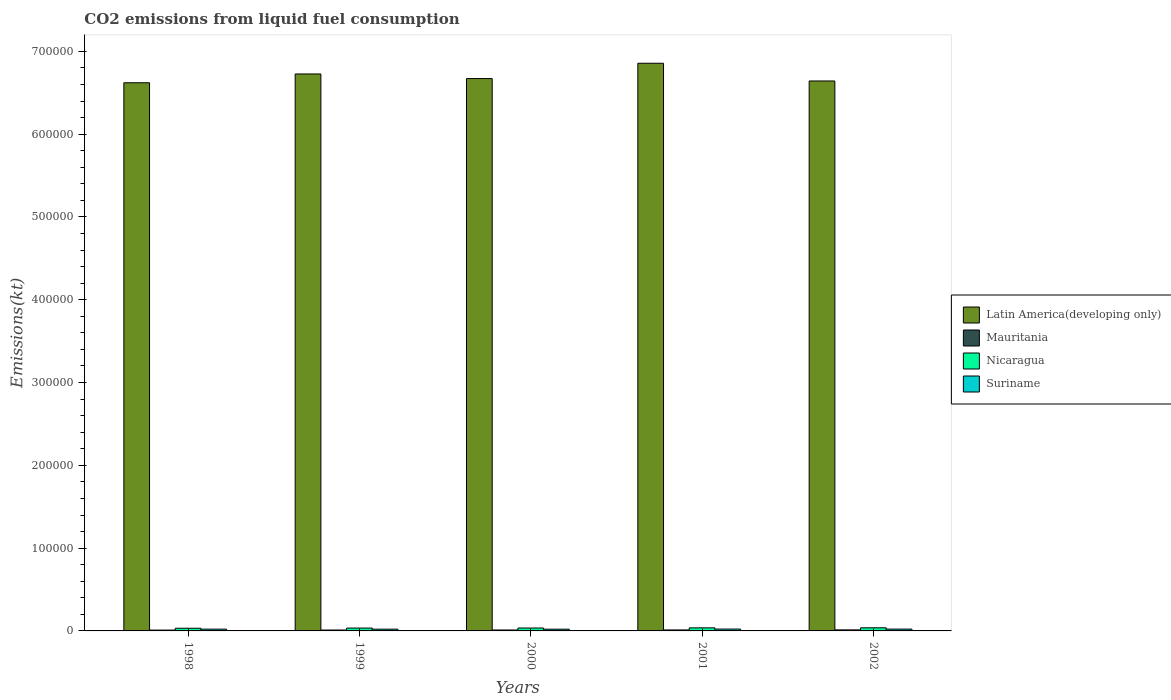How many different coloured bars are there?
Offer a very short reply. 4. How many groups of bars are there?
Provide a succinct answer. 5. Are the number of bars on each tick of the X-axis equal?
Your response must be concise. Yes. What is the label of the 1st group of bars from the left?
Give a very brief answer. 1998. In how many cases, is the number of bars for a given year not equal to the number of legend labels?
Make the answer very short. 0. What is the amount of CO2 emitted in Nicaragua in 2001?
Your answer should be very brief. 3707.34. Across all years, what is the maximum amount of CO2 emitted in Nicaragua?
Provide a succinct answer. 3762.34. Across all years, what is the minimum amount of CO2 emitted in Latin America(developing only)?
Make the answer very short. 6.62e+05. In which year was the amount of CO2 emitted in Suriname minimum?
Your answer should be compact. 2000. What is the total amount of CO2 emitted in Mauritania in the graph?
Your response must be concise. 5643.51. What is the difference between the amount of CO2 emitted in Mauritania in 1999 and that in 2002?
Ensure brevity in your answer.  -172.35. What is the difference between the amount of CO2 emitted in Suriname in 2000 and the amount of CO2 emitted in Nicaragua in 2001?
Offer a very short reply. -1609.81. What is the average amount of CO2 emitted in Nicaragua per year?
Your answer should be compact. 3530.59. In the year 2002, what is the difference between the amount of CO2 emitted in Latin America(developing only) and amount of CO2 emitted in Suriname?
Your response must be concise. 6.62e+05. What is the ratio of the amount of CO2 emitted in Mauritania in 1999 to that in 2001?
Provide a short and direct response. 0.91. Is the amount of CO2 emitted in Mauritania in 1998 less than that in 2000?
Your answer should be very brief. Yes. Is the difference between the amount of CO2 emitted in Latin America(developing only) in 2000 and 2002 greater than the difference between the amount of CO2 emitted in Suriname in 2000 and 2002?
Offer a terse response. Yes. What is the difference between the highest and the second highest amount of CO2 emitted in Mauritania?
Offer a terse response. 69.67. What is the difference between the highest and the lowest amount of CO2 emitted in Mauritania?
Your answer should be compact. 245.69. In how many years, is the amount of CO2 emitted in Mauritania greater than the average amount of CO2 emitted in Mauritania taken over all years?
Ensure brevity in your answer.  2. What does the 4th bar from the left in 2001 represents?
Provide a short and direct response. Suriname. What does the 3rd bar from the right in 1998 represents?
Give a very brief answer. Mauritania. Is it the case that in every year, the sum of the amount of CO2 emitted in Nicaragua and amount of CO2 emitted in Latin America(developing only) is greater than the amount of CO2 emitted in Suriname?
Your response must be concise. Yes. Are all the bars in the graph horizontal?
Offer a very short reply. No. What is the difference between two consecutive major ticks on the Y-axis?
Provide a succinct answer. 1.00e+05. Are the values on the major ticks of Y-axis written in scientific E-notation?
Offer a terse response. No. Does the graph contain any zero values?
Provide a succinct answer. No. Where does the legend appear in the graph?
Your response must be concise. Center right. What is the title of the graph?
Your response must be concise. CO2 emissions from liquid fuel consumption. Does "Burundi" appear as one of the legend labels in the graph?
Provide a succinct answer. No. What is the label or title of the X-axis?
Your response must be concise. Years. What is the label or title of the Y-axis?
Offer a very short reply. Emissions(kt). What is the Emissions(kt) in Latin America(developing only) in 1998?
Make the answer very short. 6.62e+05. What is the Emissions(kt) in Mauritania in 1998?
Make the answer very short. 1008.42. What is the Emissions(kt) of Nicaragua in 1998?
Offer a terse response. 3234.29. What is the Emissions(kt) of Suriname in 1998?
Your response must be concise. 2134.19. What is the Emissions(kt) of Latin America(developing only) in 1999?
Your answer should be compact. 6.73e+05. What is the Emissions(kt) in Mauritania in 1999?
Your answer should be compact. 1081.77. What is the Emissions(kt) of Nicaragua in 1999?
Make the answer very short. 3450.65. What is the Emissions(kt) of Suriname in 1999?
Make the answer very short. 2123.19. What is the Emissions(kt) in Latin America(developing only) in 2000?
Provide a short and direct response. 6.67e+05. What is the Emissions(kt) of Mauritania in 2000?
Offer a very short reply. 1114.77. What is the Emissions(kt) in Nicaragua in 2000?
Your answer should be very brief. 3498.32. What is the Emissions(kt) in Suriname in 2000?
Give a very brief answer. 2097.52. What is the Emissions(kt) in Latin America(developing only) in 2001?
Offer a terse response. 6.86e+05. What is the Emissions(kt) of Mauritania in 2001?
Keep it short and to the point. 1184.44. What is the Emissions(kt) in Nicaragua in 2001?
Your answer should be very brief. 3707.34. What is the Emissions(kt) in Suriname in 2001?
Provide a short and direct response. 2233.2. What is the Emissions(kt) in Latin America(developing only) in 2002?
Your response must be concise. 6.64e+05. What is the Emissions(kt) in Mauritania in 2002?
Provide a short and direct response. 1254.11. What is the Emissions(kt) in Nicaragua in 2002?
Provide a succinct answer. 3762.34. What is the Emissions(kt) of Suriname in 2002?
Provide a short and direct response. 2218.53. Across all years, what is the maximum Emissions(kt) of Latin America(developing only)?
Give a very brief answer. 6.86e+05. Across all years, what is the maximum Emissions(kt) of Mauritania?
Keep it short and to the point. 1254.11. Across all years, what is the maximum Emissions(kt) of Nicaragua?
Ensure brevity in your answer.  3762.34. Across all years, what is the maximum Emissions(kt) in Suriname?
Keep it short and to the point. 2233.2. Across all years, what is the minimum Emissions(kt) in Latin America(developing only)?
Offer a terse response. 6.62e+05. Across all years, what is the minimum Emissions(kt) of Mauritania?
Offer a very short reply. 1008.42. Across all years, what is the minimum Emissions(kt) of Nicaragua?
Your answer should be very brief. 3234.29. Across all years, what is the minimum Emissions(kt) of Suriname?
Your response must be concise. 2097.52. What is the total Emissions(kt) in Latin America(developing only) in the graph?
Your answer should be compact. 3.35e+06. What is the total Emissions(kt) in Mauritania in the graph?
Your answer should be very brief. 5643.51. What is the total Emissions(kt) of Nicaragua in the graph?
Your response must be concise. 1.77e+04. What is the total Emissions(kt) in Suriname in the graph?
Ensure brevity in your answer.  1.08e+04. What is the difference between the Emissions(kt) of Latin America(developing only) in 1998 and that in 1999?
Offer a terse response. -1.06e+04. What is the difference between the Emissions(kt) in Mauritania in 1998 and that in 1999?
Provide a succinct answer. -73.34. What is the difference between the Emissions(kt) in Nicaragua in 1998 and that in 1999?
Offer a terse response. -216.35. What is the difference between the Emissions(kt) of Suriname in 1998 and that in 1999?
Keep it short and to the point. 11. What is the difference between the Emissions(kt) of Latin America(developing only) in 1998 and that in 2000?
Your response must be concise. -5056.79. What is the difference between the Emissions(kt) of Mauritania in 1998 and that in 2000?
Your response must be concise. -106.34. What is the difference between the Emissions(kt) in Nicaragua in 1998 and that in 2000?
Provide a succinct answer. -264.02. What is the difference between the Emissions(kt) in Suriname in 1998 and that in 2000?
Make the answer very short. 36.67. What is the difference between the Emissions(kt) in Latin America(developing only) in 1998 and that in 2001?
Your answer should be very brief. -2.36e+04. What is the difference between the Emissions(kt) in Mauritania in 1998 and that in 2001?
Provide a succinct answer. -176.02. What is the difference between the Emissions(kt) of Nicaragua in 1998 and that in 2001?
Make the answer very short. -473.04. What is the difference between the Emissions(kt) of Suriname in 1998 and that in 2001?
Ensure brevity in your answer.  -99.01. What is the difference between the Emissions(kt) of Latin America(developing only) in 1998 and that in 2002?
Your response must be concise. -2156.2. What is the difference between the Emissions(kt) in Mauritania in 1998 and that in 2002?
Offer a very short reply. -245.69. What is the difference between the Emissions(kt) of Nicaragua in 1998 and that in 2002?
Provide a short and direct response. -528.05. What is the difference between the Emissions(kt) in Suriname in 1998 and that in 2002?
Your response must be concise. -84.34. What is the difference between the Emissions(kt) in Latin America(developing only) in 1999 and that in 2000?
Your response must be concise. 5577.51. What is the difference between the Emissions(kt) in Mauritania in 1999 and that in 2000?
Keep it short and to the point. -33. What is the difference between the Emissions(kt) in Nicaragua in 1999 and that in 2000?
Offer a terse response. -47.67. What is the difference between the Emissions(kt) of Suriname in 1999 and that in 2000?
Offer a terse response. 25.67. What is the difference between the Emissions(kt) in Latin America(developing only) in 1999 and that in 2001?
Your answer should be compact. -1.29e+04. What is the difference between the Emissions(kt) in Mauritania in 1999 and that in 2001?
Your answer should be very brief. -102.68. What is the difference between the Emissions(kt) of Nicaragua in 1999 and that in 2001?
Your answer should be very brief. -256.69. What is the difference between the Emissions(kt) of Suriname in 1999 and that in 2001?
Provide a succinct answer. -110.01. What is the difference between the Emissions(kt) of Latin America(developing only) in 1999 and that in 2002?
Give a very brief answer. 8478.1. What is the difference between the Emissions(kt) of Mauritania in 1999 and that in 2002?
Your answer should be compact. -172.35. What is the difference between the Emissions(kt) in Nicaragua in 1999 and that in 2002?
Your answer should be compact. -311.69. What is the difference between the Emissions(kt) of Suriname in 1999 and that in 2002?
Your answer should be compact. -95.34. What is the difference between the Emissions(kt) of Latin America(developing only) in 2000 and that in 2001?
Provide a short and direct response. -1.85e+04. What is the difference between the Emissions(kt) in Mauritania in 2000 and that in 2001?
Make the answer very short. -69.67. What is the difference between the Emissions(kt) in Nicaragua in 2000 and that in 2001?
Provide a succinct answer. -209.02. What is the difference between the Emissions(kt) in Suriname in 2000 and that in 2001?
Give a very brief answer. -135.68. What is the difference between the Emissions(kt) in Latin America(developing only) in 2000 and that in 2002?
Your answer should be very brief. 2900.6. What is the difference between the Emissions(kt) of Mauritania in 2000 and that in 2002?
Ensure brevity in your answer.  -139.35. What is the difference between the Emissions(kt) of Nicaragua in 2000 and that in 2002?
Your answer should be compact. -264.02. What is the difference between the Emissions(kt) in Suriname in 2000 and that in 2002?
Make the answer very short. -121.01. What is the difference between the Emissions(kt) of Latin America(developing only) in 2001 and that in 2002?
Offer a very short reply. 2.14e+04. What is the difference between the Emissions(kt) of Mauritania in 2001 and that in 2002?
Give a very brief answer. -69.67. What is the difference between the Emissions(kt) of Nicaragua in 2001 and that in 2002?
Make the answer very short. -55.01. What is the difference between the Emissions(kt) of Suriname in 2001 and that in 2002?
Your answer should be compact. 14.67. What is the difference between the Emissions(kt) of Latin America(developing only) in 1998 and the Emissions(kt) of Mauritania in 1999?
Provide a short and direct response. 6.61e+05. What is the difference between the Emissions(kt) in Latin America(developing only) in 1998 and the Emissions(kt) in Nicaragua in 1999?
Keep it short and to the point. 6.59e+05. What is the difference between the Emissions(kt) in Latin America(developing only) in 1998 and the Emissions(kt) in Suriname in 1999?
Keep it short and to the point. 6.60e+05. What is the difference between the Emissions(kt) in Mauritania in 1998 and the Emissions(kt) in Nicaragua in 1999?
Provide a succinct answer. -2442.22. What is the difference between the Emissions(kt) in Mauritania in 1998 and the Emissions(kt) in Suriname in 1999?
Keep it short and to the point. -1114.77. What is the difference between the Emissions(kt) of Nicaragua in 1998 and the Emissions(kt) of Suriname in 1999?
Your response must be concise. 1111.1. What is the difference between the Emissions(kt) of Latin America(developing only) in 1998 and the Emissions(kt) of Mauritania in 2000?
Your answer should be very brief. 6.61e+05. What is the difference between the Emissions(kt) in Latin America(developing only) in 1998 and the Emissions(kt) in Nicaragua in 2000?
Your answer should be very brief. 6.59e+05. What is the difference between the Emissions(kt) of Latin America(developing only) in 1998 and the Emissions(kt) of Suriname in 2000?
Offer a very short reply. 6.60e+05. What is the difference between the Emissions(kt) of Mauritania in 1998 and the Emissions(kt) of Nicaragua in 2000?
Give a very brief answer. -2489.89. What is the difference between the Emissions(kt) of Mauritania in 1998 and the Emissions(kt) of Suriname in 2000?
Provide a succinct answer. -1089.1. What is the difference between the Emissions(kt) in Nicaragua in 1998 and the Emissions(kt) in Suriname in 2000?
Ensure brevity in your answer.  1136.77. What is the difference between the Emissions(kt) in Latin America(developing only) in 1998 and the Emissions(kt) in Mauritania in 2001?
Keep it short and to the point. 6.61e+05. What is the difference between the Emissions(kt) of Latin America(developing only) in 1998 and the Emissions(kt) of Nicaragua in 2001?
Your answer should be compact. 6.58e+05. What is the difference between the Emissions(kt) in Latin America(developing only) in 1998 and the Emissions(kt) in Suriname in 2001?
Ensure brevity in your answer.  6.60e+05. What is the difference between the Emissions(kt) of Mauritania in 1998 and the Emissions(kt) of Nicaragua in 2001?
Your response must be concise. -2698.91. What is the difference between the Emissions(kt) of Mauritania in 1998 and the Emissions(kt) of Suriname in 2001?
Provide a succinct answer. -1224.78. What is the difference between the Emissions(kt) of Nicaragua in 1998 and the Emissions(kt) of Suriname in 2001?
Offer a terse response. 1001.09. What is the difference between the Emissions(kt) in Latin America(developing only) in 1998 and the Emissions(kt) in Mauritania in 2002?
Offer a very short reply. 6.61e+05. What is the difference between the Emissions(kt) of Latin America(developing only) in 1998 and the Emissions(kt) of Nicaragua in 2002?
Ensure brevity in your answer.  6.58e+05. What is the difference between the Emissions(kt) of Latin America(developing only) in 1998 and the Emissions(kt) of Suriname in 2002?
Ensure brevity in your answer.  6.60e+05. What is the difference between the Emissions(kt) in Mauritania in 1998 and the Emissions(kt) in Nicaragua in 2002?
Give a very brief answer. -2753.92. What is the difference between the Emissions(kt) of Mauritania in 1998 and the Emissions(kt) of Suriname in 2002?
Keep it short and to the point. -1210.11. What is the difference between the Emissions(kt) of Nicaragua in 1998 and the Emissions(kt) of Suriname in 2002?
Give a very brief answer. 1015.76. What is the difference between the Emissions(kt) of Latin America(developing only) in 1999 and the Emissions(kt) of Mauritania in 2000?
Give a very brief answer. 6.72e+05. What is the difference between the Emissions(kt) in Latin America(developing only) in 1999 and the Emissions(kt) in Nicaragua in 2000?
Ensure brevity in your answer.  6.69e+05. What is the difference between the Emissions(kt) in Latin America(developing only) in 1999 and the Emissions(kt) in Suriname in 2000?
Provide a succinct answer. 6.71e+05. What is the difference between the Emissions(kt) in Mauritania in 1999 and the Emissions(kt) in Nicaragua in 2000?
Ensure brevity in your answer.  -2416.55. What is the difference between the Emissions(kt) of Mauritania in 1999 and the Emissions(kt) of Suriname in 2000?
Ensure brevity in your answer.  -1015.76. What is the difference between the Emissions(kt) in Nicaragua in 1999 and the Emissions(kt) in Suriname in 2000?
Your response must be concise. 1353.12. What is the difference between the Emissions(kt) of Latin America(developing only) in 1999 and the Emissions(kt) of Mauritania in 2001?
Provide a succinct answer. 6.72e+05. What is the difference between the Emissions(kt) of Latin America(developing only) in 1999 and the Emissions(kt) of Nicaragua in 2001?
Provide a succinct answer. 6.69e+05. What is the difference between the Emissions(kt) of Latin America(developing only) in 1999 and the Emissions(kt) of Suriname in 2001?
Offer a very short reply. 6.71e+05. What is the difference between the Emissions(kt) in Mauritania in 1999 and the Emissions(kt) in Nicaragua in 2001?
Keep it short and to the point. -2625.57. What is the difference between the Emissions(kt) of Mauritania in 1999 and the Emissions(kt) of Suriname in 2001?
Provide a succinct answer. -1151.44. What is the difference between the Emissions(kt) of Nicaragua in 1999 and the Emissions(kt) of Suriname in 2001?
Make the answer very short. 1217.44. What is the difference between the Emissions(kt) of Latin America(developing only) in 1999 and the Emissions(kt) of Mauritania in 2002?
Make the answer very short. 6.71e+05. What is the difference between the Emissions(kt) in Latin America(developing only) in 1999 and the Emissions(kt) in Nicaragua in 2002?
Ensure brevity in your answer.  6.69e+05. What is the difference between the Emissions(kt) in Latin America(developing only) in 1999 and the Emissions(kt) in Suriname in 2002?
Provide a short and direct response. 6.71e+05. What is the difference between the Emissions(kt) in Mauritania in 1999 and the Emissions(kt) in Nicaragua in 2002?
Keep it short and to the point. -2680.58. What is the difference between the Emissions(kt) in Mauritania in 1999 and the Emissions(kt) in Suriname in 2002?
Provide a succinct answer. -1136.77. What is the difference between the Emissions(kt) in Nicaragua in 1999 and the Emissions(kt) in Suriname in 2002?
Offer a terse response. 1232.11. What is the difference between the Emissions(kt) in Latin America(developing only) in 2000 and the Emissions(kt) in Mauritania in 2001?
Your answer should be very brief. 6.66e+05. What is the difference between the Emissions(kt) of Latin America(developing only) in 2000 and the Emissions(kt) of Nicaragua in 2001?
Give a very brief answer. 6.63e+05. What is the difference between the Emissions(kt) in Latin America(developing only) in 2000 and the Emissions(kt) in Suriname in 2001?
Offer a terse response. 6.65e+05. What is the difference between the Emissions(kt) of Mauritania in 2000 and the Emissions(kt) of Nicaragua in 2001?
Give a very brief answer. -2592.57. What is the difference between the Emissions(kt) in Mauritania in 2000 and the Emissions(kt) in Suriname in 2001?
Make the answer very short. -1118.43. What is the difference between the Emissions(kt) of Nicaragua in 2000 and the Emissions(kt) of Suriname in 2001?
Provide a short and direct response. 1265.12. What is the difference between the Emissions(kt) in Latin America(developing only) in 2000 and the Emissions(kt) in Mauritania in 2002?
Provide a succinct answer. 6.66e+05. What is the difference between the Emissions(kt) of Latin America(developing only) in 2000 and the Emissions(kt) of Nicaragua in 2002?
Keep it short and to the point. 6.63e+05. What is the difference between the Emissions(kt) of Latin America(developing only) in 2000 and the Emissions(kt) of Suriname in 2002?
Your answer should be compact. 6.65e+05. What is the difference between the Emissions(kt) in Mauritania in 2000 and the Emissions(kt) in Nicaragua in 2002?
Provide a succinct answer. -2647.57. What is the difference between the Emissions(kt) in Mauritania in 2000 and the Emissions(kt) in Suriname in 2002?
Give a very brief answer. -1103.77. What is the difference between the Emissions(kt) in Nicaragua in 2000 and the Emissions(kt) in Suriname in 2002?
Make the answer very short. 1279.78. What is the difference between the Emissions(kt) in Latin America(developing only) in 2001 and the Emissions(kt) in Mauritania in 2002?
Your answer should be very brief. 6.84e+05. What is the difference between the Emissions(kt) of Latin America(developing only) in 2001 and the Emissions(kt) of Nicaragua in 2002?
Provide a short and direct response. 6.82e+05. What is the difference between the Emissions(kt) in Latin America(developing only) in 2001 and the Emissions(kt) in Suriname in 2002?
Provide a short and direct response. 6.83e+05. What is the difference between the Emissions(kt) of Mauritania in 2001 and the Emissions(kt) of Nicaragua in 2002?
Provide a succinct answer. -2577.9. What is the difference between the Emissions(kt) in Mauritania in 2001 and the Emissions(kt) in Suriname in 2002?
Make the answer very short. -1034.09. What is the difference between the Emissions(kt) in Nicaragua in 2001 and the Emissions(kt) in Suriname in 2002?
Provide a short and direct response. 1488.8. What is the average Emissions(kt) in Latin America(developing only) per year?
Your answer should be very brief. 6.70e+05. What is the average Emissions(kt) in Mauritania per year?
Provide a short and direct response. 1128.7. What is the average Emissions(kt) in Nicaragua per year?
Ensure brevity in your answer.  3530.59. What is the average Emissions(kt) in Suriname per year?
Provide a succinct answer. 2161.33. In the year 1998, what is the difference between the Emissions(kt) of Latin America(developing only) and Emissions(kt) of Mauritania?
Offer a very short reply. 6.61e+05. In the year 1998, what is the difference between the Emissions(kt) in Latin America(developing only) and Emissions(kt) in Nicaragua?
Ensure brevity in your answer.  6.59e+05. In the year 1998, what is the difference between the Emissions(kt) of Latin America(developing only) and Emissions(kt) of Suriname?
Give a very brief answer. 6.60e+05. In the year 1998, what is the difference between the Emissions(kt) of Mauritania and Emissions(kt) of Nicaragua?
Give a very brief answer. -2225.87. In the year 1998, what is the difference between the Emissions(kt) in Mauritania and Emissions(kt) in Suriname?
Offer a very short reply. -1125.77. In the year 1998, what is the difference between the Emissions(kt) in Nicaragua and Emissions(kt) in Suriname?
Your answer should be compact. 1100.1. In the year 1999, what is the difference between the Emissions(kt) of Latin America(developing only) and Emissions(kt) of Mauritania?
Provide a succinct answer. 6.72e+05. In the year 1999, what is the difference between the Emissions(kt) in Latin America(developing only) and Emissions(kt) in Nicaragua?
Your response must be concise. 6.69e+05. In the year 1999, what is the difference between the Emissions(kt) of Latin America(developing only) and Emissions(kt) of Suriname?
Offer a very short reply. 6.71e+05. In the year 1999, what is the difference between the Emissions(kt) of Mauritania and Emissions(kt) of Nicaragua?
Ensure brevity in your answer.  -2368.88. In the year 1999, what is the difference between the Emissions(kt) of Mauritania and Emissions(kt) of Suriname?
Your answer should be very brief. -1041.43. In the year 1999, what is the difference between the Emissions(kt) in Nicaragua and Emissions(kt) in Suriname?
Give a very brief answer. 1327.45. In the year 2000, what is the difference between the Emissions(kt) of Latin America(developing only) and Emissions(kt) of Mauritania?
Ensure brevity in your answer.  6.66e+05. In the year 2000, what is the difference between the Emissions(kt) of Latin America(developing only) and Emissions(kt) of Nicaragua?
Your response must be concise. 6.64e+05. In the year 2000, what is the difference between the Emissions(kt) in Latin America(developing only) and Emissions(kt) in Suriname?
Your answer should be very brief. 6.65e+05. In the year 2000, what is the difference between the Emissions(kt) in Mauritania and Emissions(kt) in Nicaragua?
Provide a short and direct response. -2383.55. In the year 2000, what is the difference between the Emissions(kt) in Mauritania and Emissions(kt) in Suriname?
Your answer should be compact. -982.76. In the year 2000, what is the difference between the Emissions(kt) of Nicaragua and Emissions(kt) of Suriname?
Provide a succinct answer. 1400.79. In the year 2001, what is the difference between the Emissions(kt) in Latin America(developing only) and Emissions(kt) in Mauritania?
Provide a short and direct response. 6.84e+05. In the year 2001, what is the difference between the Emissions(kt) in Latin America(developing only) and Emissions(kt) in Nicaragua?
Provide a succinct answer. 6.82e+05. In the year 2001, what is the difference between the Emissions(kt) in Latin America(developing only) and Emissions(kt) in Suriname?
Make the answer very short. 6.83e+05. In the year 2001, what is the difference between the Emissions(kt) of Mauritania and Emissions(kt) of Nicaragua?
Keep it short and to the point. -2522.9. In the year 2001, what is the difference between the Emissions(kt) of Mauritania and Emissions(kt) of Suriname?
Provide a short and direct response. -1048.76. In the year 2001, what is the difference between the Emissions(kt) in Nicaragua and Emissions(kt) in Suriname?
Offer a very short reply. 1474.13. In the year 2002, what is the difference between the Emissions(kt) in Latin America(developing only) and Emissions(kt) in Mauritania?
Your answer should be compact. 6.63e+05. In the year 2002, what is the difference between the Emissions(kt) in Latin America(developing only) and Emissions(kt) in Nicaragua?
Your answer should be very brief. 6.61e+05. In the year 2002, what is the difference between the Emissions(kt) in Latin America(developing only) and Emissions(kt) in Suriname?
Provide a succinct answer. 6.62e+05. In the year 2002, what is the difference between the Emissions(kt) of Mauritania and Emissions(kt) of Nicaragua?
Give a very brief answer. -2508.23. In the year 2002, what is the difference between the Emissions(kt) in Mauritania and Emissions(kt) in Suriname?
Your answer should be very brief. -964.42. In the year 2002, what is the difference between the Emissions(kt) of Nicaragua and Emissions(kt) of Suriname?
Offer a very short reply. 1543.81. What is the ratio of the Emissions(kt) in Latin America(developing only) in 1998 to that in 1999?
Give a very brief answer. 0.98. What is the ratio of the Emissions(kt) of Mauritania in 1998 to that in 1999?
Your answer should be compact. 0.93. What is the ratio of the Emissions(kt) in Nicaragua in 1998 to that in 1999?
Provide a succinct answer. 0.94. What is the ratio of the Emissions(kt) of Latin America(developing only) in 1998 to that in 2000?
Provide a succinct answer. 0.99. What is the ratio of the Emissions(kt) in Mauritania in 1998 to that in 2000?
Make the answer very short. 0.9. What is the ratio of the Emissions(kt) in Nicaragua in 1998 to that in 2000?
Keep it short and to the point. 0.92. What is the ratio of the Emissions(kt) of Suriname in 1998 to that in 2000?
Make the answer very short. 1.02. What is the ratio of the Emissions(kt) of Latin America(developing only) in 1998 to that in 2001?
Offer a terse response. 0.97. What is the ratio of the Emissions(kt) in Mauritania in 1998 to that in 2001?
Offer a very short reply. 0.85. What is the ratio of the Emissions(kt) in Nicaragua in 1998 to that in 2001?
Keep it short and to the point. 0.87. What is the ratio of the Emissions(kt) of Suriname in 1998 to that in 2001?
Provide a short and direct response. 0.96. What is the ratio of the Emissions(kt) of Latin America(developing only) in 1998 to that in 2002?
Keep it short and to the point. 1. What is the ratio of the Emissions(kt) in Mauritania in 1998 to that in 2002?
Give a very brief answer. 0.8. What is the ratio of the Emissions(kt) of Nicaragua in 1998 to that in 2002?
Keep it short and to the point. 0.86. What is the ratio of the Emissions(kt) of Latin America(developing only) in 1999 to that in 2000?
Your answer should be compact. 1.01. What is the ratio of the Emissions(kt) in Mauritania in 1999 to that in 2000?
Keep it short and to the point. 0.97. What is the ratio of the Emissions(kt) in Nicaragua in 1999 to that in 2000?
Keep it short and to the point. 0.99. What is the ratio of the Emissions(kt) of Suriname in 1999 to that in 2000?
Provide a succinct answer. 1.01. What is the ratio of the Emissions(kt) of Latin America(developing only) in 1999 to that in 2001?
Offer a very short reply. 0.98. What is the ratio of the Emissions(kt) in Mauritania in 1999 to that in 2001?
Make the answer very short. 0.91. What is the ratio of the Emissions(kt) of Nicaragua in 1999 to that in 2001?
Offer a terse response. 0.93. What is the ratio of the Emissions(kt) in Suriname in 1999 to that in 2001?
Give a very brief answer. 0.95. What is the ratio of the Emissions(kt) in Latin America(developing only) in 1999 to that in 2002?
Provide a short and direct response. 1.01. What is the ratio of the Emissions(kt) in Mauritania in 1999 to that in 2002?
Ensure brevity in your answer.  0.86. What is the ratio of the Emissions(kt) of Nicaragua in 1999 to that in 2002?
Your response must be concise. 0.92. What is the ratio of the Emissions(kt) in Suriname in 1999 to that in 2002?
Offer a terse response. 0.96. What is the ratio of the Emissions(kt) in Mauritania in 2000 to that in 2001?
Ensure brevity in your answer.  0.94. What is the ratio of the Emissions(kt) in Nicaragua in 2000 to that in 2001?
Your answer should be compact. 0.94. What is the ratio of the Emissions(kt) in Suriname in 2000 to that in 2001?
Keep it short and to the point. 0.94. What is the ratio of the Emissions(kt) in Nicaragua in 2000 to that in 2002?
Offer a terse response. 0.93. What is the ratio of the Emissions(kt) of Suriname in 2000 to that in 2002?
Offer a very short reply. 0.95. What is the ratio of the Emissions(kt) in Latin America(developing only) in 2001 to that in 2002?
Your response must be concise. 1.03. What is the ratio of the Emissions(kt) of Mauritania in 2001 to that in 2002?
Offer a very short reply. 0.94. What is the ratio of the Emissions(kt) of Nicaragua in 2001 to that in 2002?
Provide a short and direct response. 0.99. What is the ratio of the Emissions(kt) of Suriname in 2001 to that in 2002?
Make the answer very short. 1.01. What is the difference between the highest and the second highest Emissions(kt) of Latin America(developing only)?
Your response must be concise. 1.29e+04. What is the difference between the highest and the second highest Emissions(kt) in Mauritania?
Your response must be concise. 69.67. What is the difference between the highest and the second highest Emissions(kt) of Nicaragua?
Your response must be concise. 55.01. What is the difference between the highest and the second highest Emissions(kt) in Suriname?
Offer a terse response. 14.67. What is the difference between the highest and the lowest Emissions(kt) in Latin America(developing only)?
Your answer should be very brief. 2.36e+04. What is the difference between the highest and the lowest Emissions(kt) of Mauritania?
Keep it short and to the point. 245.69. What is the difference between the highest and the lowest Emissions(kt) of Nicaragua?
Provide a succinct answer. 528.05. What is the difference between the highest and the lowest Emissions(kt) of Suriname?
Ensure brevity in your answer.  135.68. 